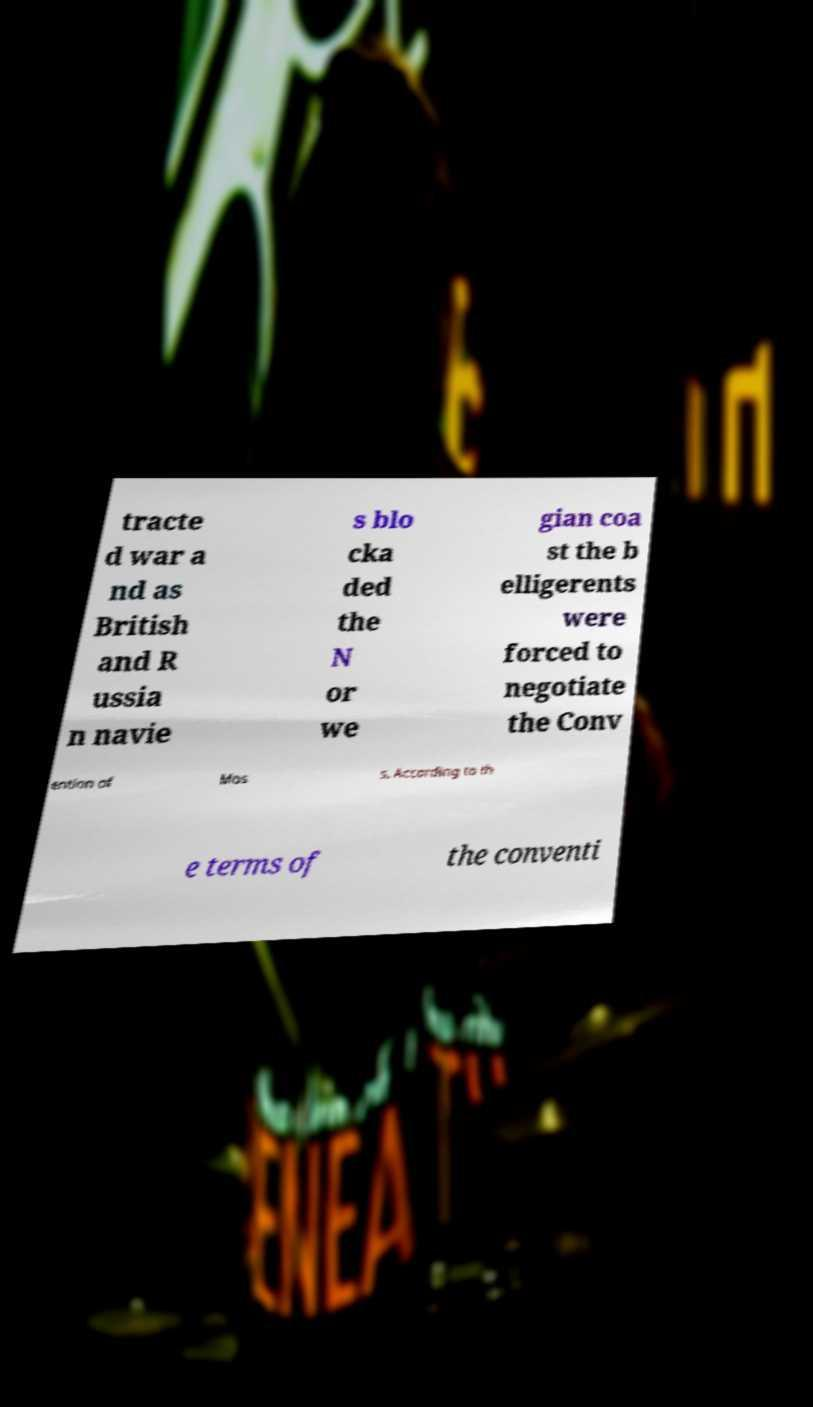There's text embedded in this image that I need extracted. Can you transcribe it verbatim? tracte d war a nd as British and R ussia n navie s blo cka ded the N or we gian coa st the b elligerents were forced to negotiate the Conv ention of Mos s. According to th e terms of the conventi 